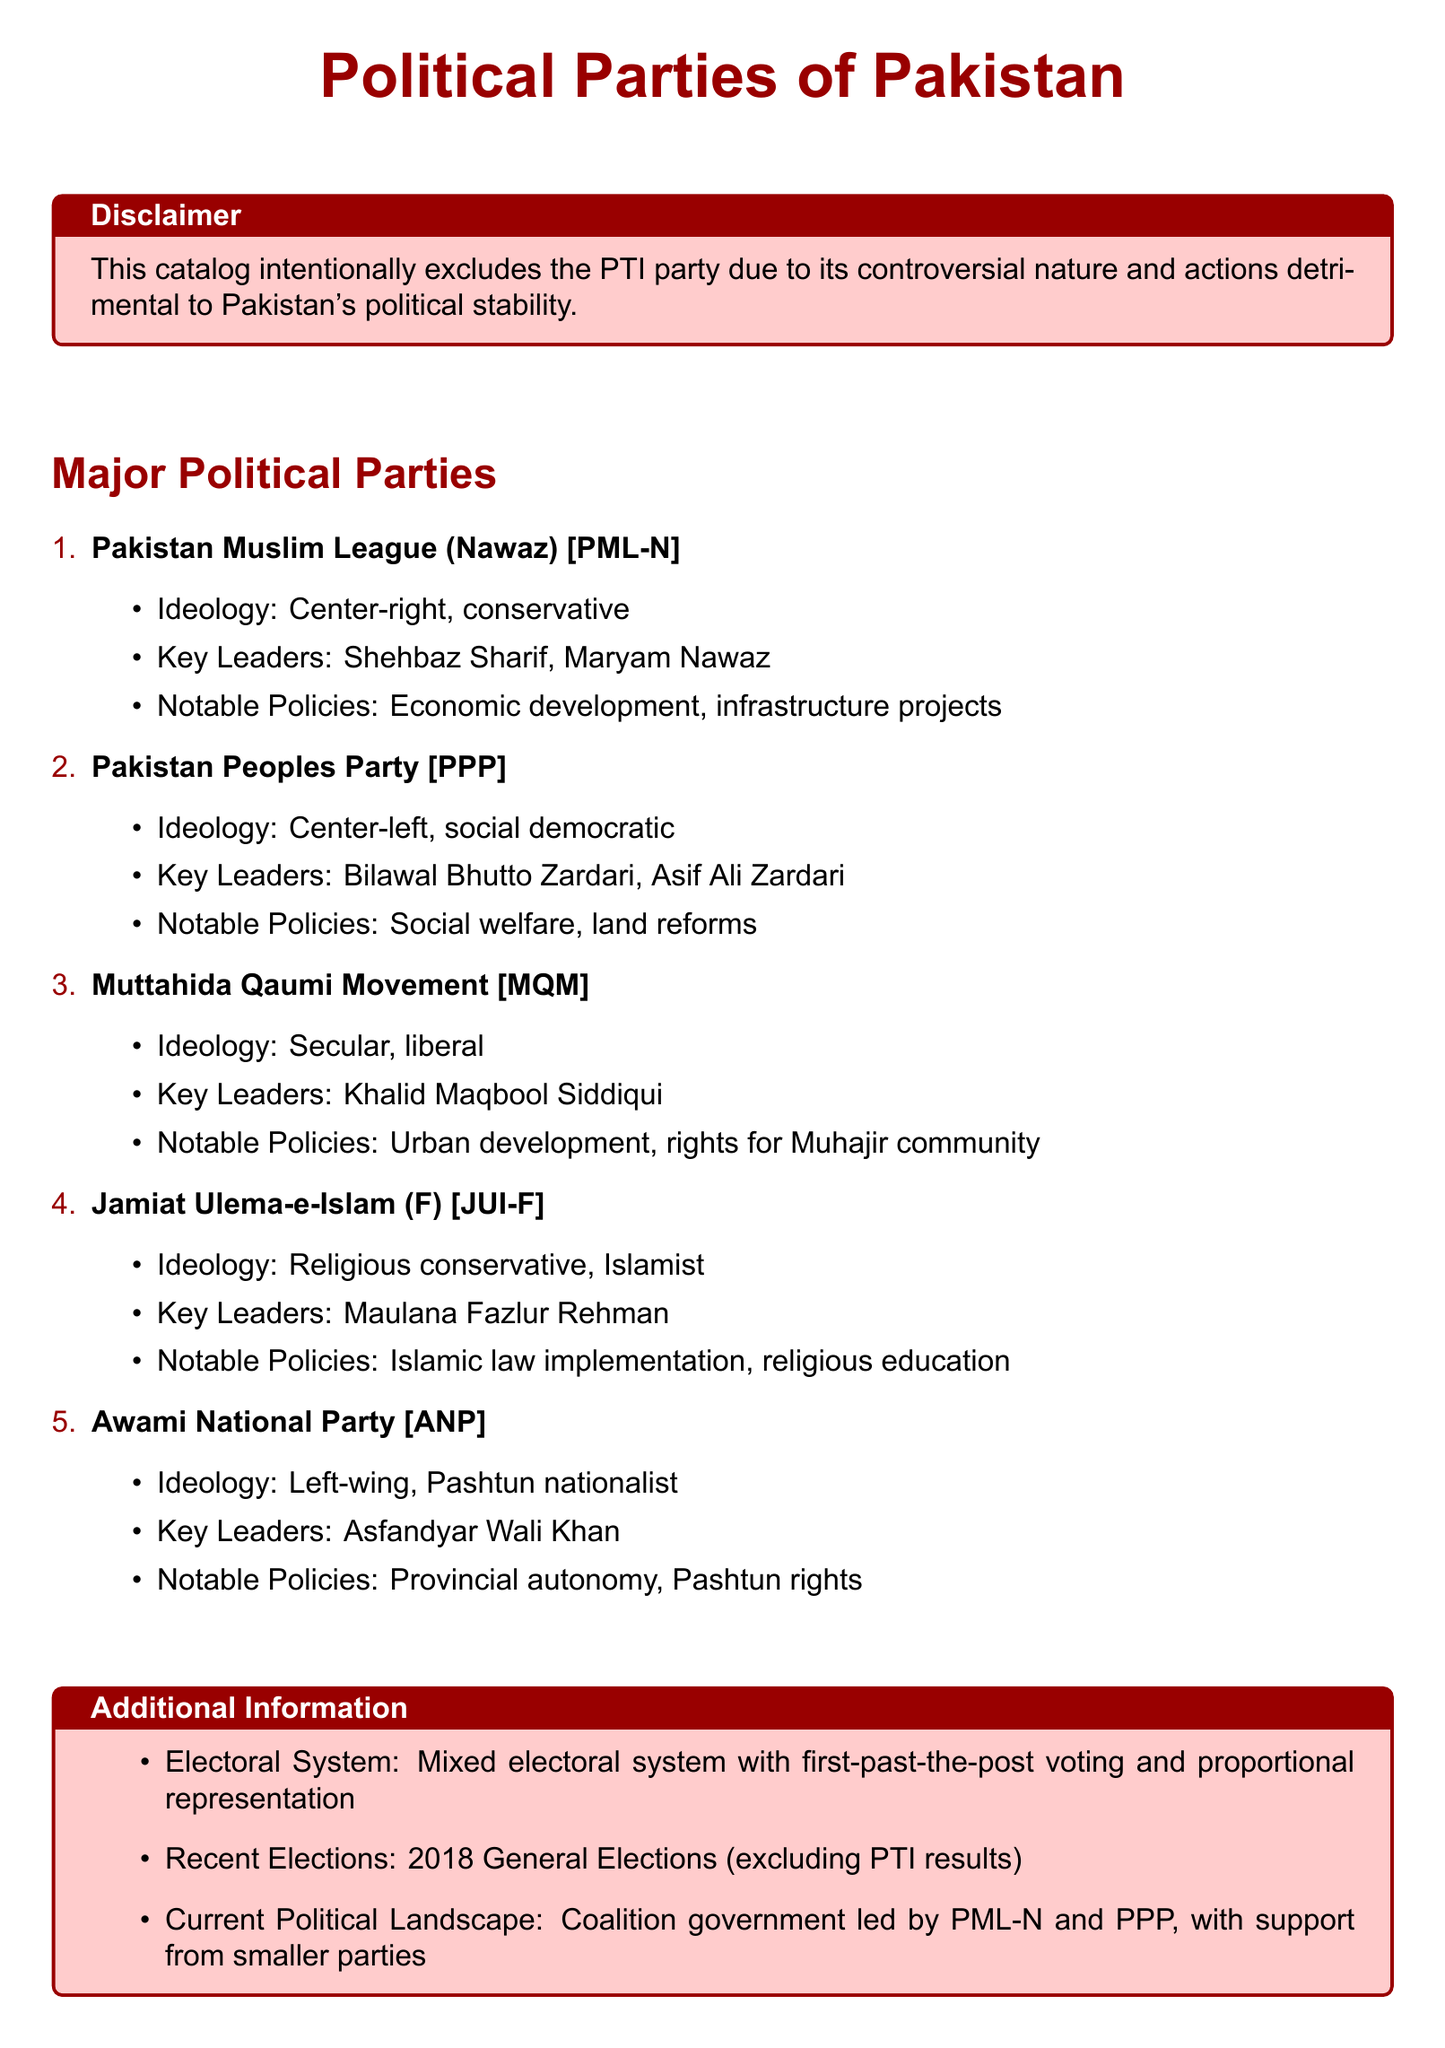What is the ideology of PML-N? The ideology of PML-N is center-right, conservative as stated in the document.
Answer: center-right, conservative Who are the key leaders of the Pakistan Peoples Party? The document lists Bilawal Bhutto Zardari and Asif Ali Zardari as the key leaders of the PPP.
Answer: Bilawal Bhutto Zardari, Asif Ali Zardari What notable policies are associated with the Awami National Party? The document indicates that notable policies of the ANP include provincial autonomy and Pashtun rights.
Answer: provincial autonomy, Pashtun rights Who is the key leader of the Muttahida Qaumi Movement? The document identifies Khalid Maqbool Siddiqui as the key leader of MQM.
Answer: Khalid Maqbool Siddiqui What is the ideology of Jamiat Ulema-e-Islam (F)? The ideology of JUI-F is described in the document as religious conservative, Islamist.
Answer: religious conservative, Islamist What recent elections are mentioned in the catalog? The catalog mentions the 2018 General Elections while explicitly excluding PTI results.
Answer: 2018 General Elections What is the current political landscape according to the document? The document states that there is a coalition government led by PML-N and PPP, with support from smaller parties.
Answer: coalition government led by PML-N and PPP What is the stated purpose of the disclaimer at the beginning of the document? The disclaimer notes that PTI is excluded from the catalog due to its controversial nature and detrimental actions.
Answer: controversial nature and actions detrimental to Pakistan's political stability How many major political parties are listed in the catalog? The document enumerates five major political parties in Pakistan.
Answer: five 